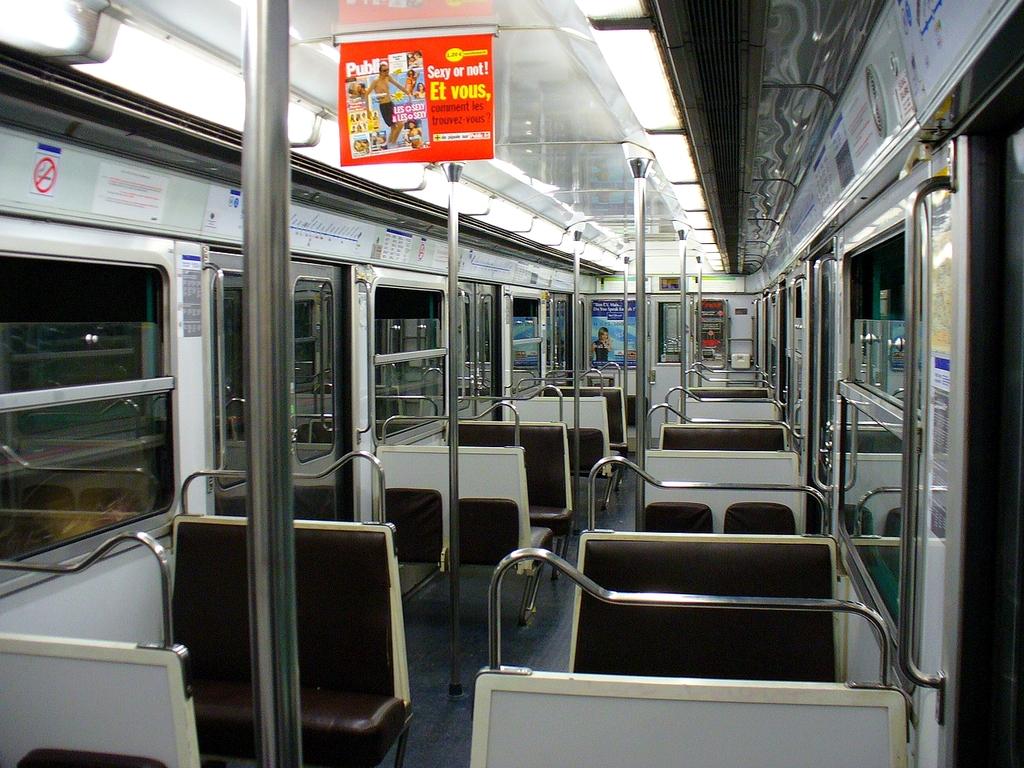What question is the magazine asking?
Your response must be concise. Unanswerable. 